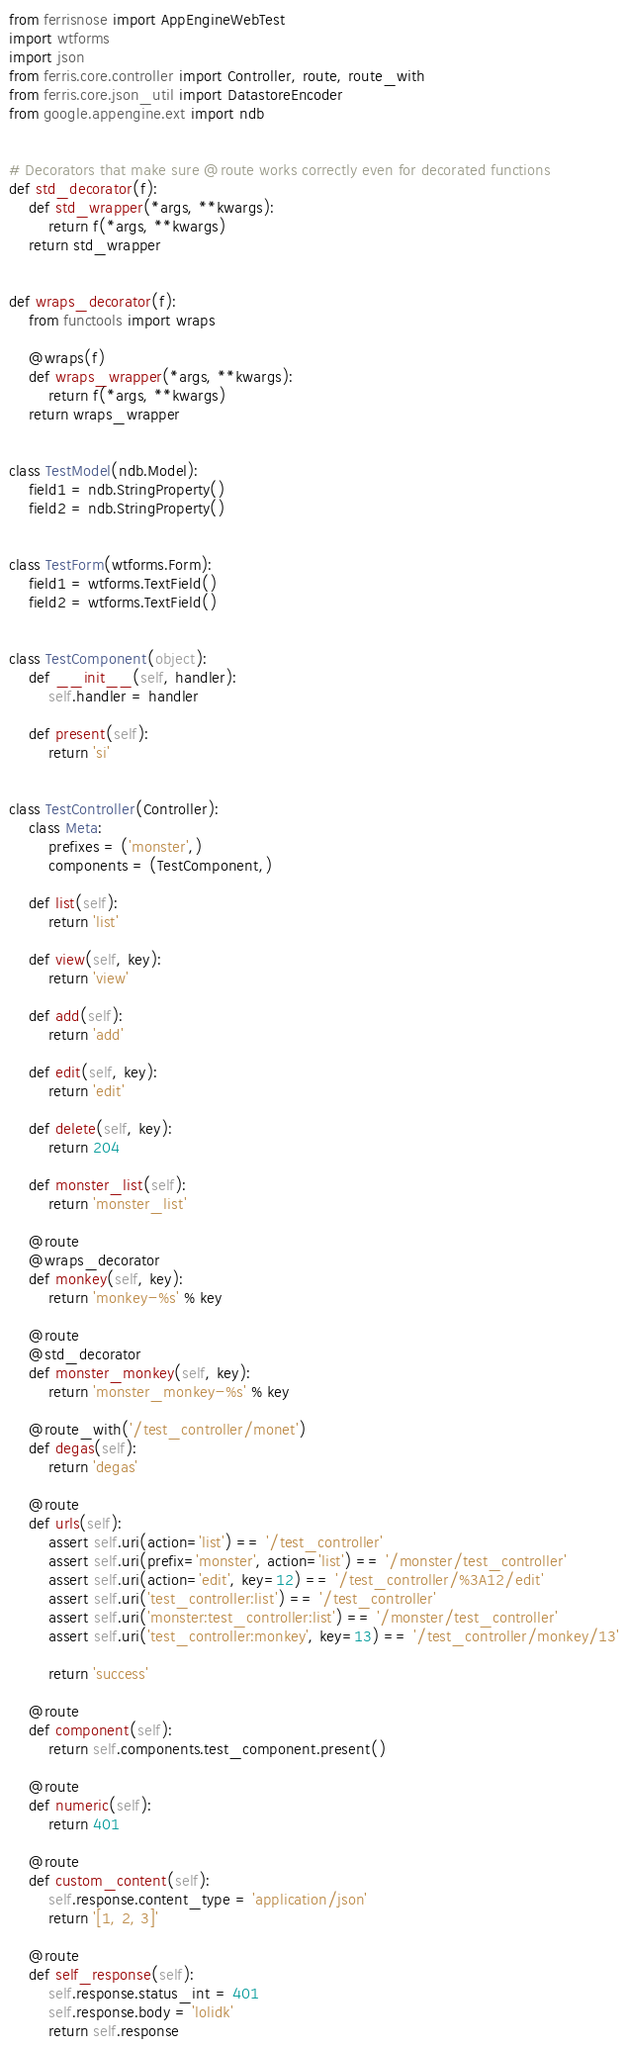<code> <loc_0><loc_0><loc_500><loc_500><_Python_>from ferrisnose import AppEngineWebTest
import wtforms
import json
from ferris.core.controller import Controller, route, route_with
from ferris.core.json_util import DatastoreEncoder
from google.appengine.ext import ndb


# Decorators that make sure @route works correctly even for decorated functions
def std_decorator(f):
    def std_wrapper(*args, **kwargs):
        return f(*args, **kwargs)
    return std_wrapper


def wraps_decorator(f):
    from functools import wraps

    @wraps(f)
    def wraps_wrapper(*args, **kwargs):
        return f(*args, **kwargs)
    return wraps_wrapper


class TestModel(ndb.Model):
    field1 = ndb.StringProperty()
    field2 = ndb.StringProperty()


class TestForm(wtforms.Form):
    field1 = wtforms.TextField()
    field2 = wtforms.TextField()


class TestComponent(object):
    def __init__(self, handler):
        self.handler = handler

    def present(self):
        return 'si'


class TestController(Controller):
    class Meta:
        prefixes = ('monster',)
        components = (TestComponent,)

    def list(self):
        return 'list'

    def view(self, key):
        return 'view'

    def add(self):
        return 'add'

    def edit(self, key):
        return 'edit'

    def delete(self, key):
        return 204

    def monster_list(self):
        return 'monster_list'

    @route
    @wraps_decorator
    def monkey(self, key):
        return 'monkey-%s' % key

    @route
    @std_decorator
    def monster_monkey(self, key):
        return 'monster_monkey-%s' % key

    @route_with('/test_controller/monet')
    def degas(self):
        return 'degas'

    @route
    def urls(self):
        assert self.uri(action='list') == '/test_controller'
        assert self.uri(prefix='monster', action='list') == '/monster/test_controller'
        assert self.uri(action='edit', key=12) == '/test_controller/%3A12/edit'
        assert self.uri('test_controller:list') == '/test_controller'
        assert self.uri('monster:test_controller:list') == '/monster/test_controller'
        assert self.uri('test_controller:monkey', key=13) == '/test_controller/monkey/13'

        return 'success'

    @route
    def component(self):
        return self.components.test_component.present()

    @route
    def numeric(self):
        return 401

    @route
    def custom_content(self):
        self.response.content_type = 'application/json'
        return '[1, 2, 3]'

    @route
    def self_response(self):
        self.response.status_int = 401
        self.response.body = 'lolidk'
        return self.response
</code> 